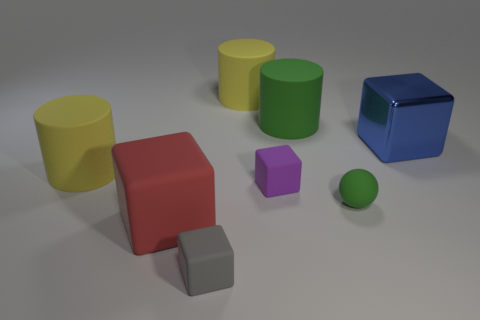There is a yellow matte thing in front of the green cylinder; what size is it?
Provide a short and direct response. Large. There is a small block that is on the left side of the purple cube; are there any rubber cylinders on the left side of it?
Give a very brief answer. Yes. Are the sphere and the big green cylinder made of the same material?
Provide a succinct answer. Yes. There is a small object that is both behind the red object and left of the small sphere; what shape is it?
Offer a terse response. Cube. There is a yellow rubber cylinder in front of the yellow rubber cylinder behind the big green rubber thing; what is its size?
Your answer should be compact. Large. What number of tiny purple matte things are the same shape as the blue shiny object?
Offer a terse response. 1. Are there any other things that have the same shape as the tiny green matte object?
Ensure brevity in your answer.  No. Are there any large rubber cylinders that have the same color as the tiny matte sphere?
Offer a very short reply. Yes. Does the green object left of the green matte sphere have the same material as the big yellow cylinder on the left side of the large red rubber thing?
Your answer should be compact. Yes. The sphere has what color?
Offer a terse response. Green. 